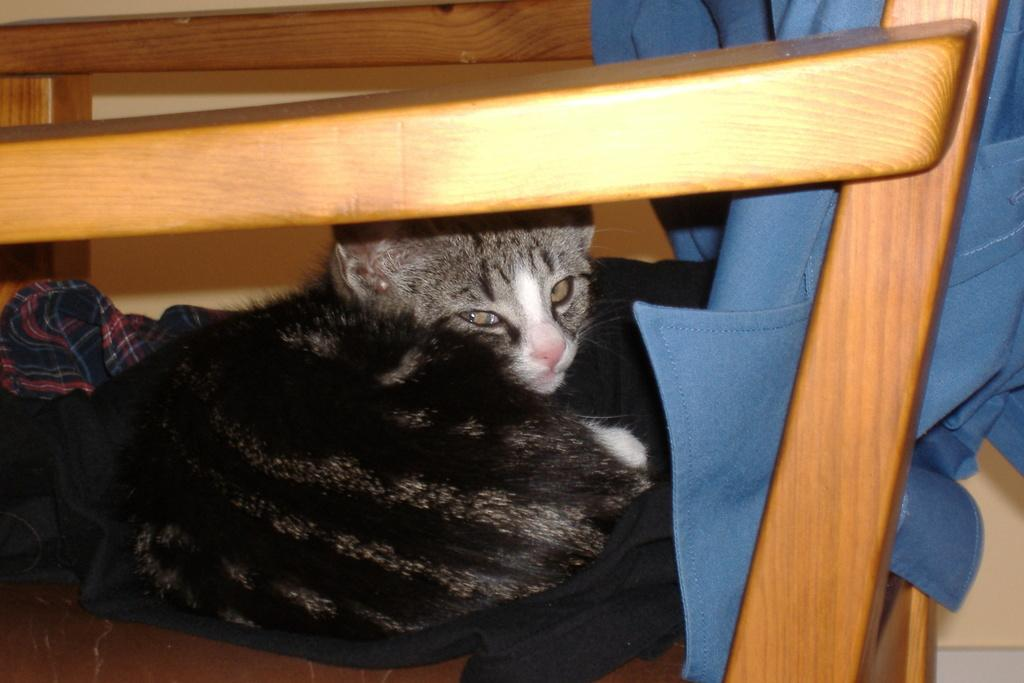What type of animal is in the image? There is a cat in the image. What is the cat laying on? The cat is laying on a black cloth. Where is the black cloth placed? The black cloth is placed on a chair. What color is the shirt visible in the background? There is a blue shirt in the background of the image. Can you solve the riddle that the cat is holding in the image? There is no riddle present in the image, as it features a cat laying on a black cloth placed on a chair. 